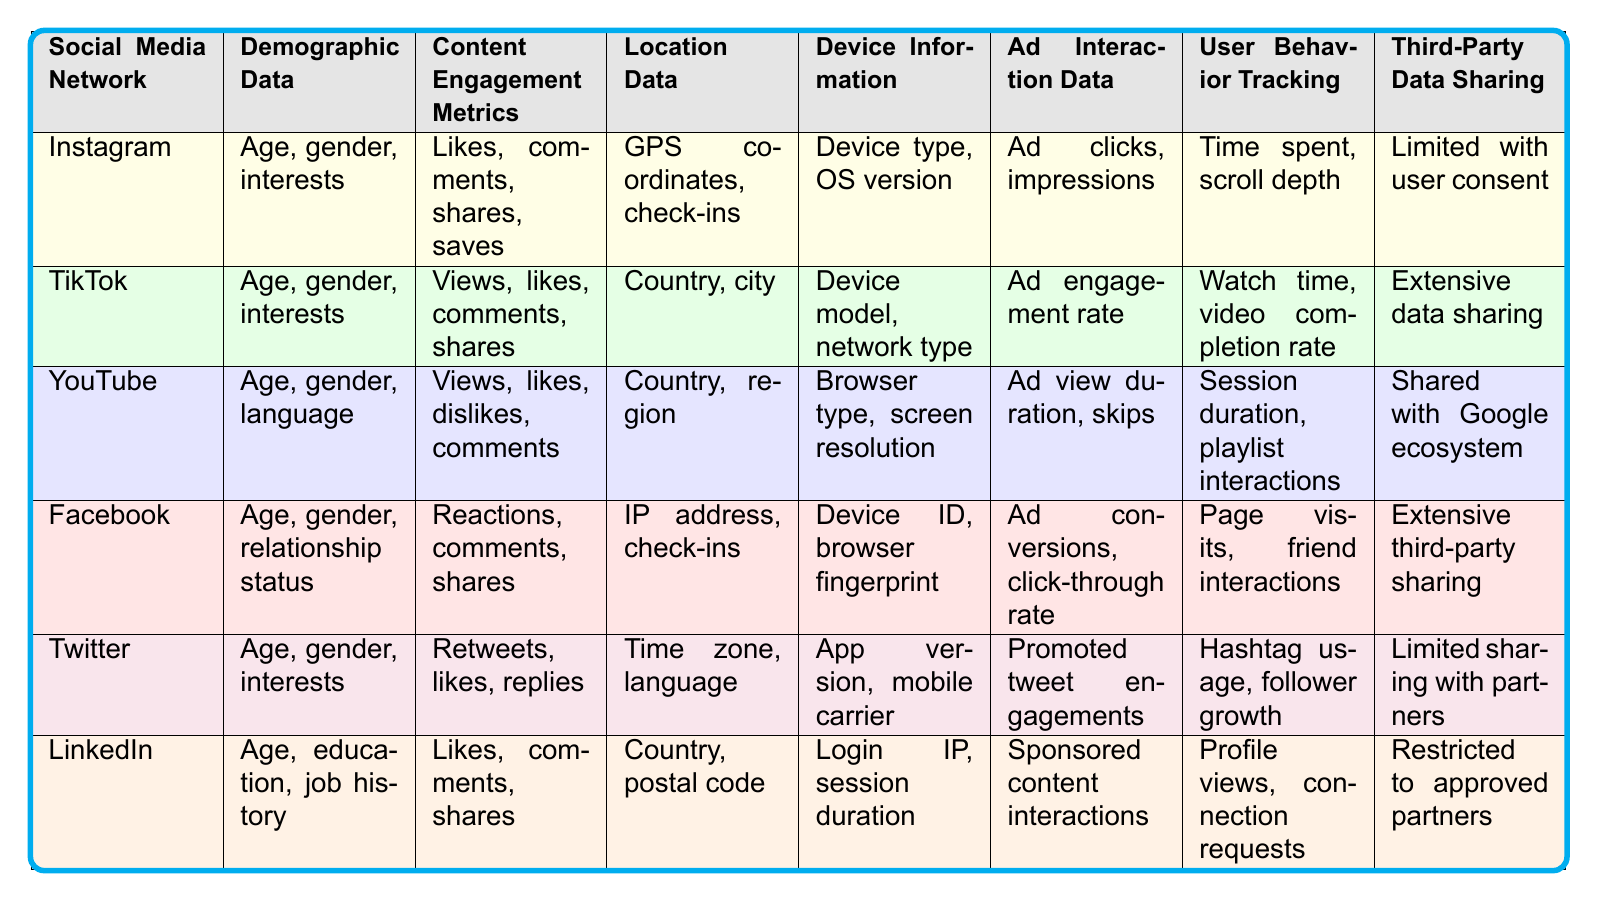What types of demographic data does TikTok collect from influencers? TikTok collects age, gender, and interests as demographic data from influencers, as indicated in the "Demographic Data" column for TikTok.
Answer: Age, gender, interests Which social media network restricts third-party data sharing the most? LinkedIn restricts third-party data sharing to approved partners, as shown in the "Third-Party Data Sharing" column for LinkedIn.
Answer: LinkedIn Do all listed social media networks collect location data? Yes, all listed social media networks collect some form of location data, as this information is present in the "Location Data" column for each network.
Answer: Yes What is the device information tracked by Facebook? Facebook tracks device ID and browser fingerprint as device information, as specified in the "Device Information" column for Facebook.
Answer: Device ID, browser fingerprint Which platform has the most extensive third-party data sharing? Facebook has extensive third-party sharing, detailed in the "Third-Party Data Sharing" column for Facebook, compared to others which have varying levels of data sharing.
Answer: Facebook How many social media platforms collect user behavior tracking data? All six platforms collect user behavior tracking data, as each entry under the "User Behavior Tracking" column contains information about engagement and interactions.
Answer: Six Which platform has the highest focus on content engagement metrics? TikTok emphasizes content engagement metrics with views, likes, comments, and shares, as visible in the "Content Engagement Metrics" column detailing TikTok’s metrics.
Answer: TikTok What kind of ad interaction data does YouTube track? YouTube tracks ad view duration and skips as ad interaction data, as seen in the relevant column for YouTube.
Answer: Ad view duration, skips Is it true that Twitter shares a lot of third-party data? No, Twitter has limited sharing with partners, which indicates that it does not extensively share data as per the information provided in the "Third-Party Data Sharing" column.
Answer: No Which platforms collect age and gender as demographic data? Instagram, TikTok, YouTube, Facebook, and Twitter collect both age and gender, as noted in their respective "Demographic Data" columns.
Answer: Five platforms 